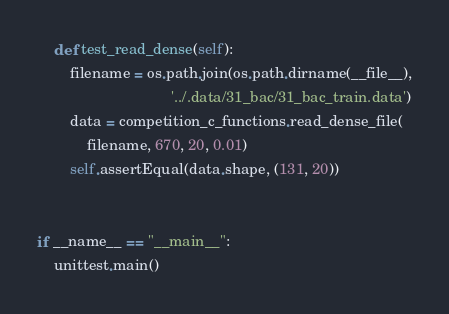<code> <loc_0><loc_0><loc_500><loc_500><_Python_>    def test_read_dense(self):
        filename = os.path.join(os.path.dirname(__file__),
                                '../.data/31_bac/31_bac_train.data')
        data = competition_c_functions.read_dense_file(
            filename, 670, 20, 0.01)
        self.assertEqual(data.shape, (131, 20))


if __name__ == "__main__":
    unittest.main()
</code> 